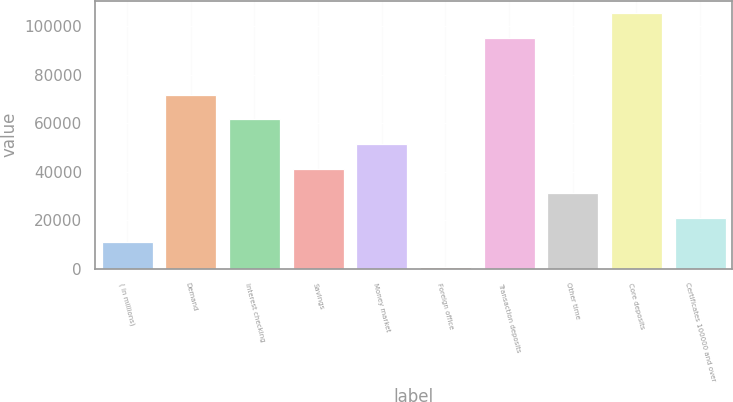<chart> <loc_0><loc_0><loc_500><loc_500><bar_chart><fcel>( in millions)<fcel>Demand<fcel>Interest checking<fcel>Savings<fcel>Money market<fcel>Foreign office<fcel>Transaction deposits<fcel>Other time<fcel>Core deposits<fcel>Certificates 100000 and over<nl><fcel>10957.4<fcel>71799.8<fcel>61659.4<fcel>41378.6<fcel>51519<fcel>817<fcel>95244<fcel>31238.2<fcel>105384<fcel>21097.8<nl></chart> 